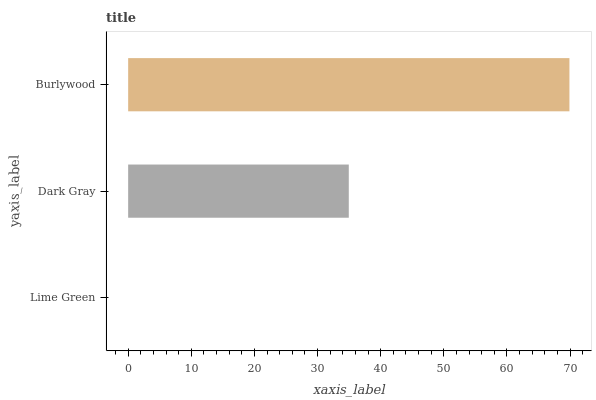Is Lime Green the minimum?
Answer yes or no. Yes. Is Burlywood the maximum?
Answer yes or no. Yes. Is Dark Gray the minimum?
Answer yes or no. No. Is Dark Gray the maximum?
Answer yes or no. No. Is Dark Gray greater than Lime Green?
Answer yes or no. Yes. Is Lime Green less than Dark Gray?
Answer yes or no. Yes. Is Lime Green greater than Dark Gray?
Answer yes or no. No. Is Dark Gray less than Lime Green?
Answer yes or no. No. Is Dark Gray the high median?
Answer yes or no. Yes. Is Dark Gray the low median?
Answer yes or no. Yes. Is Burlywood the high median?
Answer yes or no. No. Is Lime Green the low median?
Answer yes or no. No. 